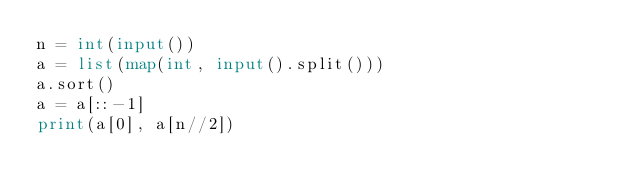Convert code to text. <code><loc_0><loc_0><loc_500><loc_500><_Python_>n = int(input())
a = list(map(int, input().split()))
a.sort()
a = a[::-1]
print(a[0], a[n//2])</code> 